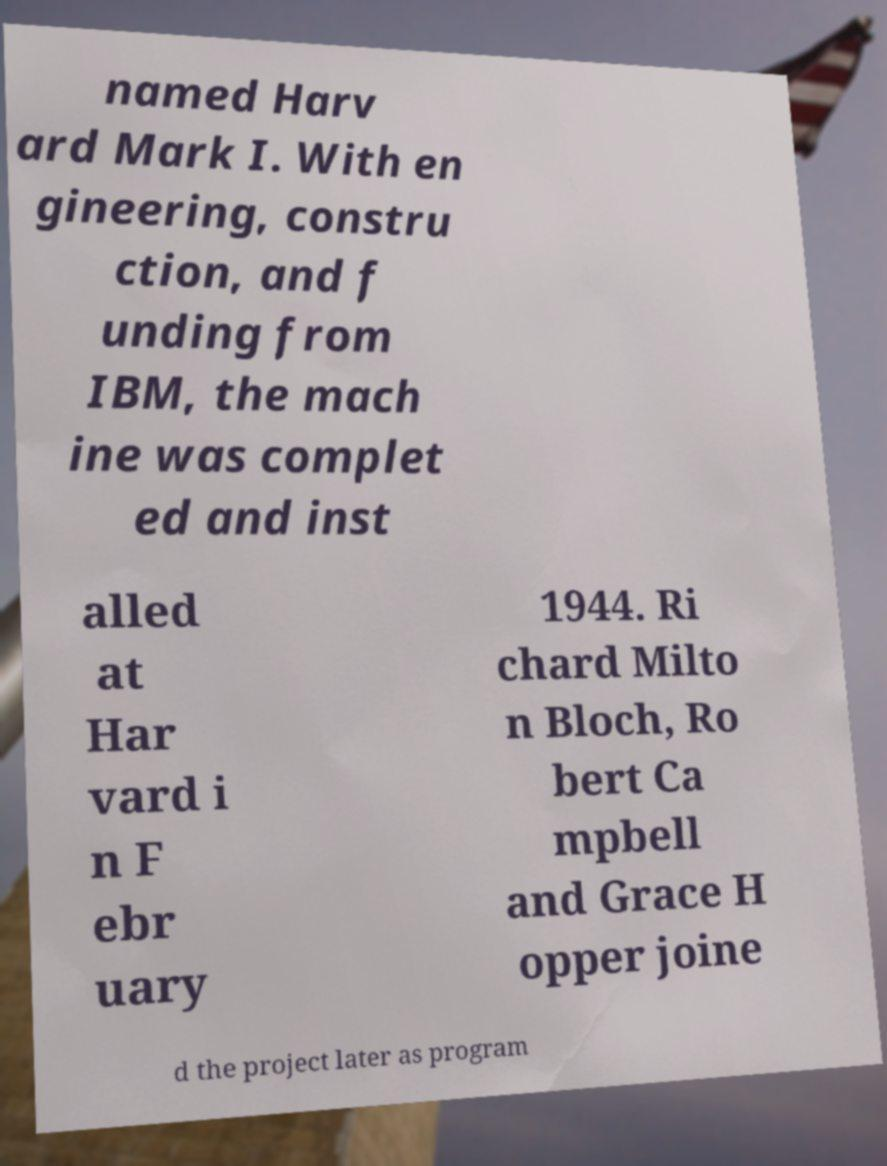Could you assist in decoding the text presented in this image and type it out clearly? named Harv ard Mark I. With en gineering, constru ction, and f unding from IBM, the mach ine was complet ed and inst alled at Har vard i n F ebr uary 1944. Ri chard Milto n Bloch, Ro bert Ca mpbell and Grace H opper joine d the project later as program 